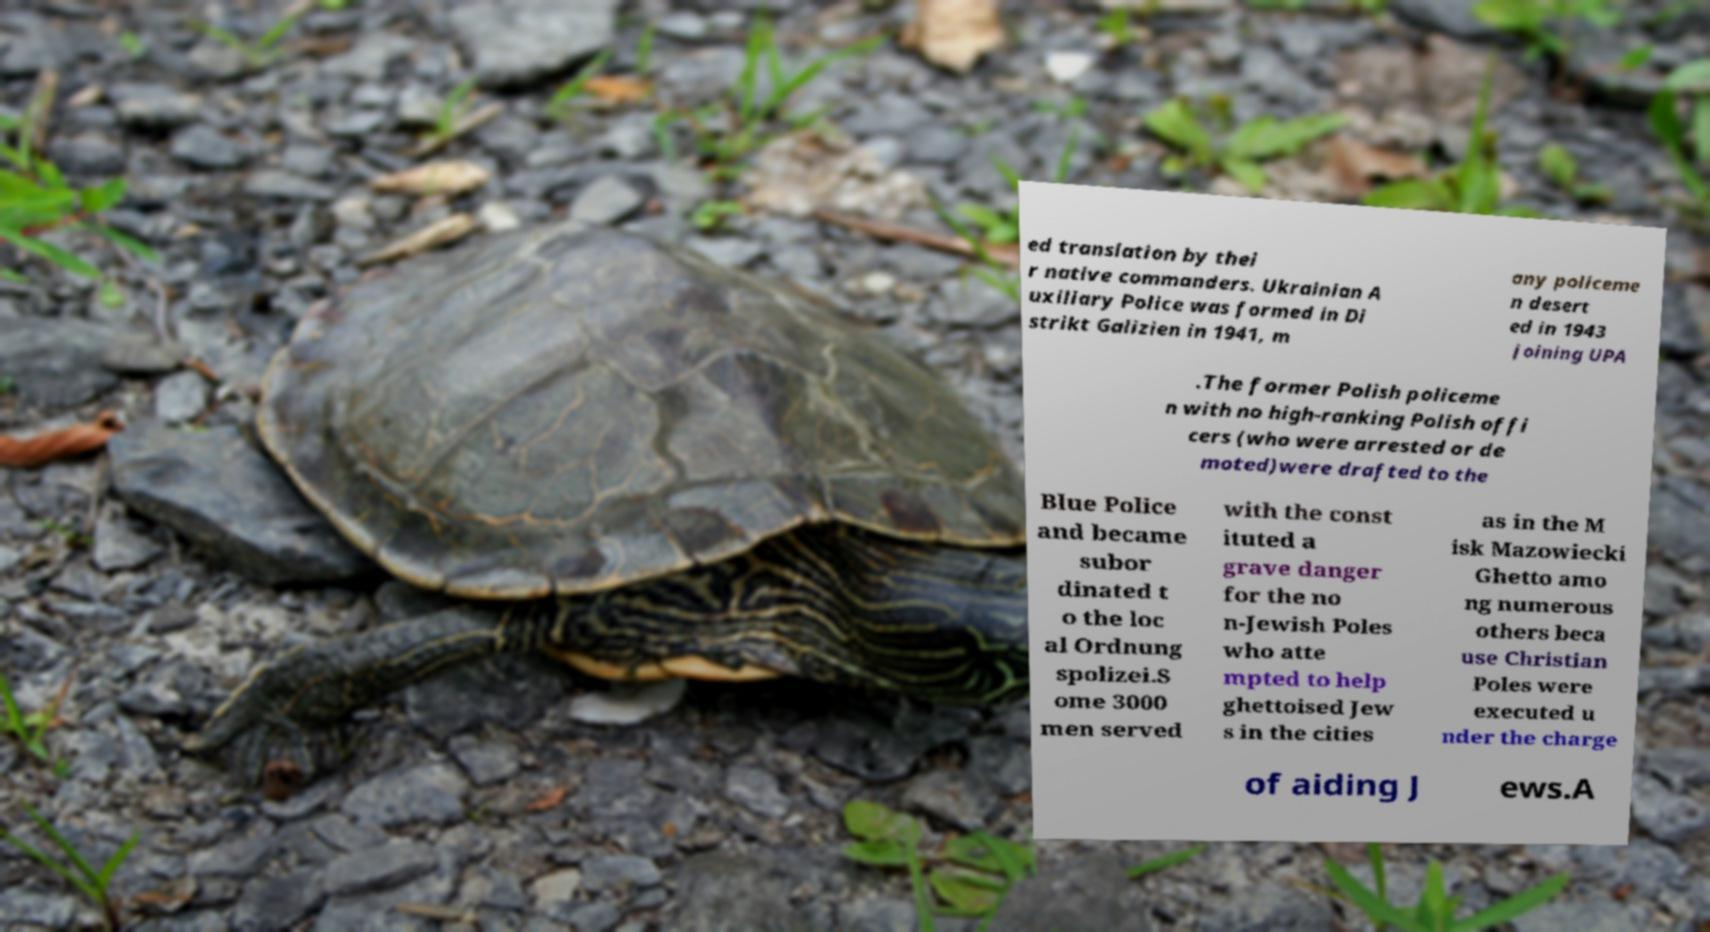Could you assist in decoding the text presented in this image and type it out clearly? ed translation by thei r native commanders. Ukrainian A uxiliary Police was formed in Di strikt Galizien in 1941, m any policeme n desert ed in 1943 joining UPA .The former Polish policeme n with no high-ranking Polish offi cers (who were arrested or de moted)were drafted to the Blue Police and became subor dinated t o the loc al Ordnung spolizei.S ome 3000 men served with the const ituted a grave danger for the no n-Jewish Poles who atte mpted to help ghettoised Jew s in the cities as in the M isk Mazowiecki Ghetto amo ng numerous others beca use Christian Poles were executed u nder the charge of aiding J ews.A 